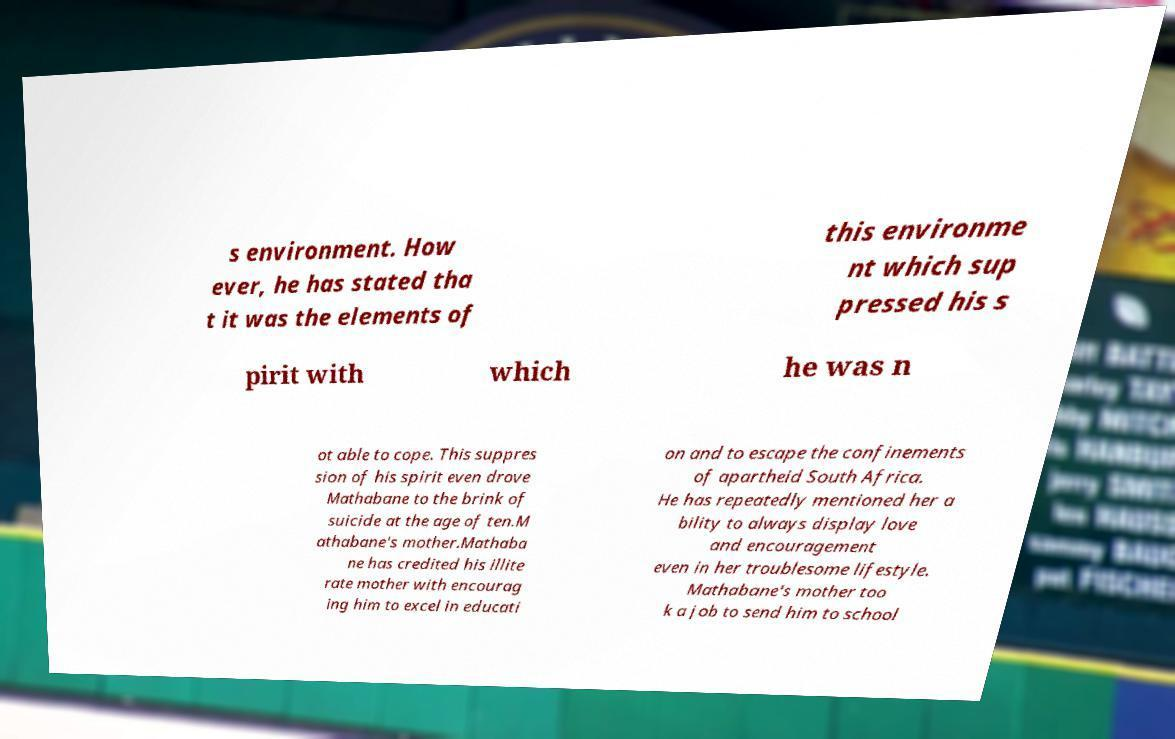For documentation purposes, I need the text within this image transcribed. Could you provide that? s environment. How ever, he has stated tha t it was the elements of this environme nt which sup pressed his s pirit with which he was n ot able to cope. This suppres sion of his spirit even drove Mathabane to the brink of suicide at the age of ten.M athabane's mother.Mathaba ne has credited his illite rate mother with encourag ing him to excel in educati on and to escape the confinements of apartheid South Africa. He has repeatedly mentioned her a bility to always display love and encouragement even in her troublesome lifestyle. Mathabane's mother too k a job to send him to school 